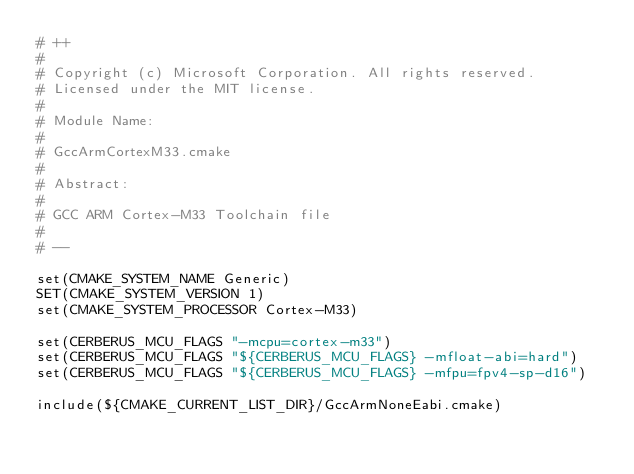<code> <loc_0><loc_0><loc_500><loc_500><_CMake_># ++
#
# Copyright (c) Microsoft Corporation. All rights reserved.
# Licensed under the MIT license.
#
# Module Name:
#
#	GccArmCortexM33.cmake
#
# Abstract:
#
#	GCC ARM Cortex-M33 Toolchain file
#
# --

set(CMAKE_SYSTEM_NAME Generic)
SET(CMAKE_SYSTEM_VERSION 1)
set(CMAKE_SYSTEM_PROCESSOR Cortex-M33)

set(CERBERUS_MCU_FLAGS "-mcpu=cortex-m33")
set(CERBERUS_MCU_FLAGS "${CERBERUS_MCU_FLAGS} -mfloat-abi=hard")
set(CERBERUS_MCU_FLAGS "${CERBERUS_MCU_FLAGS} -mfpu=fpv4-sp-d16")

include(${CMAKE_CURRENT_LIST_DIR}/GccArmNoneEabi.cmake)
</code> 